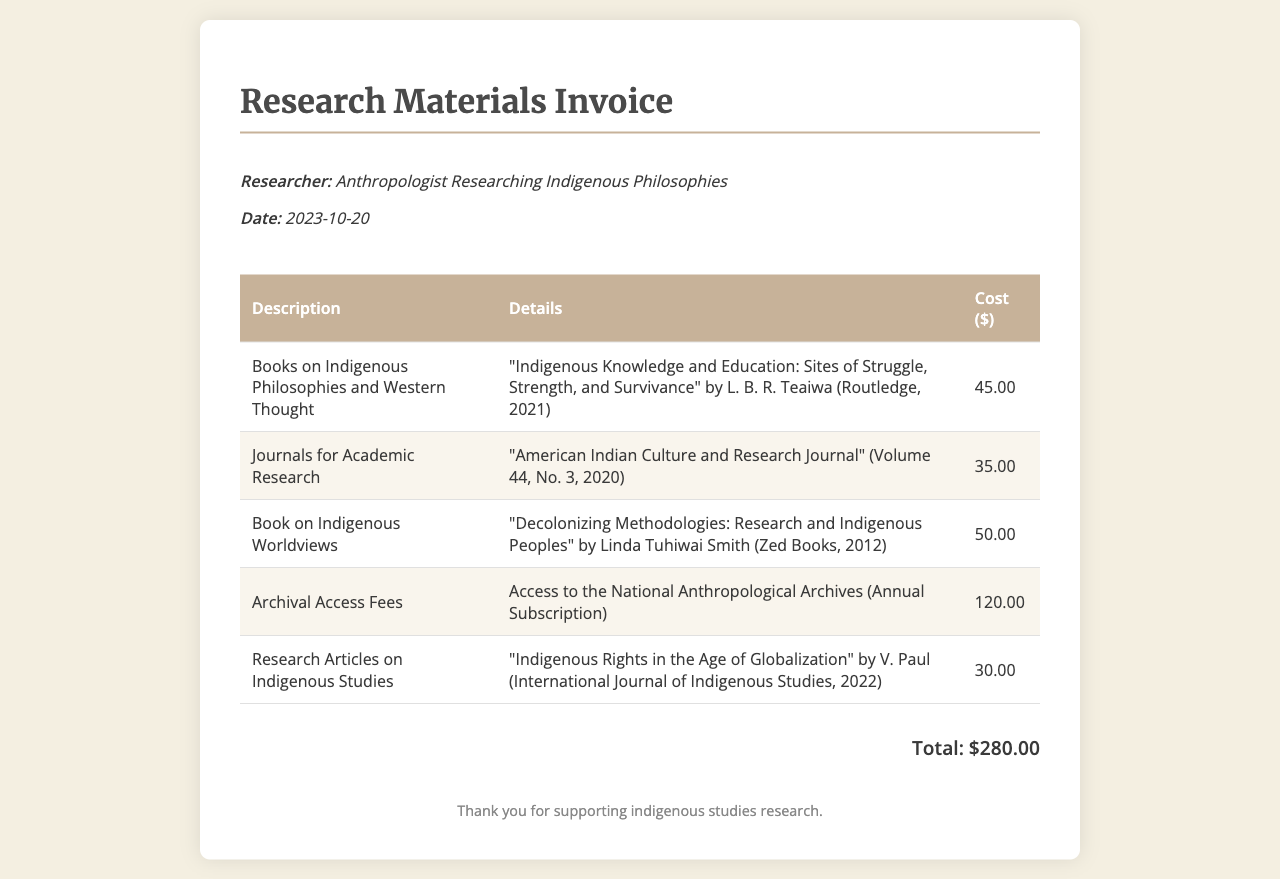what is the total cost of the invoice? The total cost is presented at the end of the invoice and sums up all the individual items listed.
Answer: $280.00 who is the researcher listed on the invoice? The researcher is identified in the researcher info section at the top of the invoice.
Answer: Anthropologist Researching Indigenous Philosophies what is the date of the invoice? The date is mentioned in the header section of the document.
Answer: 2023-10-20 how much does access to the National Anthropological Archives cost? This cost is detailed in the itemized list within the invoice.
Answer: 120.00 which book is priced at $50.00? This information can be found in the itemized list of resources along with their respective costs.
Answer: "Decolonizing Methodologies: Research and Indigenous Peoples" what journal is included in the invoice? There is a specific journal title referenced in the itemized list that is part of the invoice.
Answer: "American Indian Culture and Research Journal" how many items are listed in the invoice? The total number of items can be counted in the itemized table provided in the document.
Answer: 5 which publisher produced the book by Linda Tuhiwai Smith? The publisher's name is mentioned in the details of the item in the invoice.
Answer: Zed Books what is the title of the book by L. B. R. Teaiwa? The title can be found as part of the description in the invoice items section.
Answer: "Indigenous Knowledge and Education: Sites of Struggle, Strength, and Survivance" 